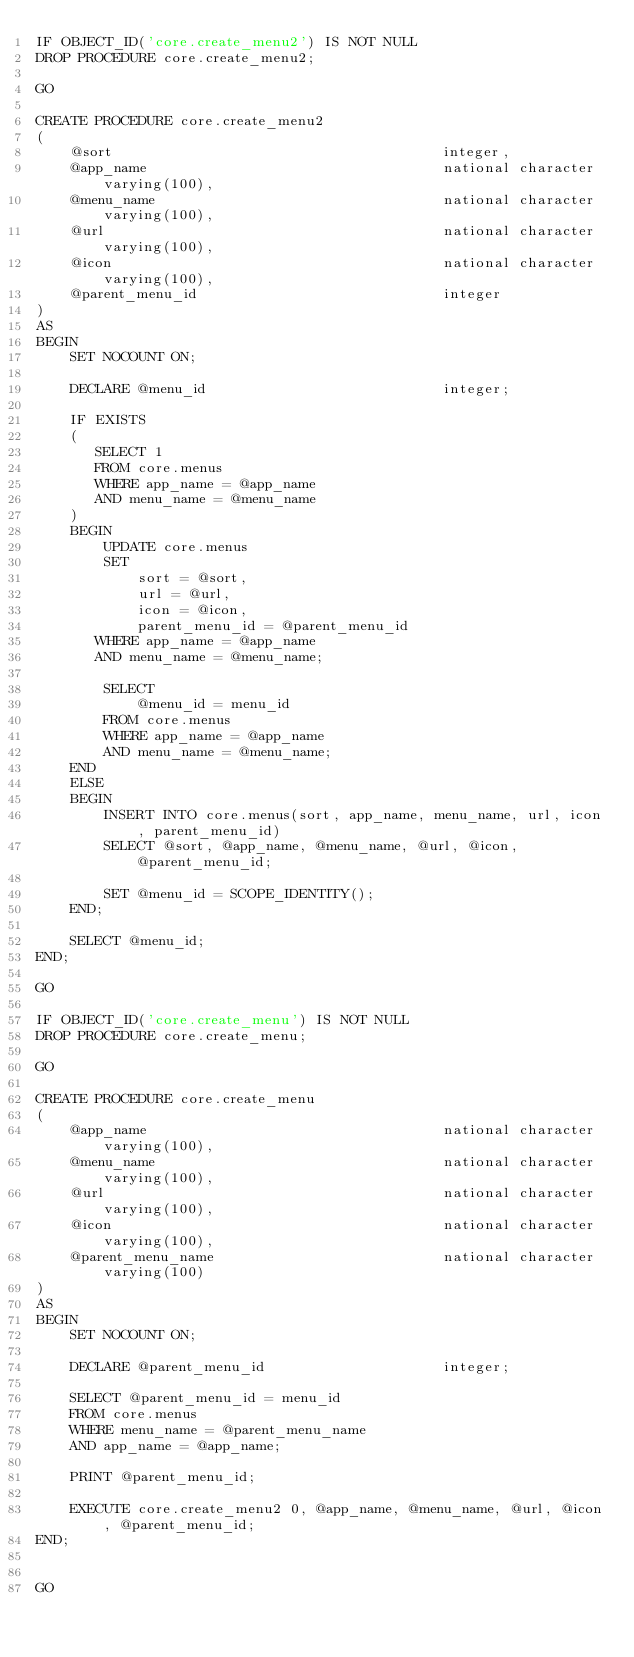<code> <loc_0><loc_0><loc_500><loc_500><_SQL_>IF OBJECT_ID('core.create_menu2') IS NOT NULL
DROP PROCEDURE core.create_menu2;

GO

CREATE PROCEDURE core.create_menu2
(
    @sort                                       integer,
    @app_name                                   national character varying(100),
    @menu_name                                  national character varying(100),
    @url                                        national character varying(100),
    @icon                                       national character varying(100),
    @parent_menu_id                             integer
)
AS
BEGIN
    SET NOCOUNT ON;

    DECLARE @menu_id                            integer;
    
    IF EXISTS
    (
       SELECT 1
       FROM core.menus
       WHERE app_name = @app_name
       AND menu_name = @menu_name
    )
    BEGIN
        UPDATE core.menus
        SET
            sort = @sort,
            url = @url,
            icon = @icon,
            parent_menu_id = @parent_menu_id
       WHERE app_name = @app_name
       AND menu_name = @menu_name;
       
		SELECT
			@menu_id = menu_id
		FROM core.menus
		WHERE app_name = @app_name
		AND menu_name = @menu_name;
    END
    ELSE
    BEGIN
        INSERT INTO core.menus(sort, app_name, menu_name, url, icon, parent_menu_id)
        SELECT @sort, @app_name, @menu_name, @url, @icon, @parent_menu_id;
        
		SET @menu_id = SCOPE_IDENTITY();
    END;

    SELECT @menu_id;
END;

GO

IF OBJECT_ID('core.create_menu') IS NOT NULL
DROP PROCEDURE core.create_menu;

GO

CREATE PROCEDURE core.create_menu
(
    @app_name                                   national character varying(100),
    @menu_name                                  national character varying(100),
    @url                                        national character varying(100),
    @icon                                       national character varying(100),
    @parent_menu_name                           national character varying(100)
)
AS
BEGIN
    SET NOCOUNT ON;

    DECLARE @parent_menu_id                     integer;

    SELECT @parent_menu_id = menu_id
    FROM core.menus
    WHERE menu_name = @parent_menu_name
    AND app_name = @app_name;
	
	PRINT @parent_menu_id;
	
    EXECUTE core.create_menu2 0, @app_name, @menu_name, @url, @icon, @parent_menu_id;
END;


GO</code> 